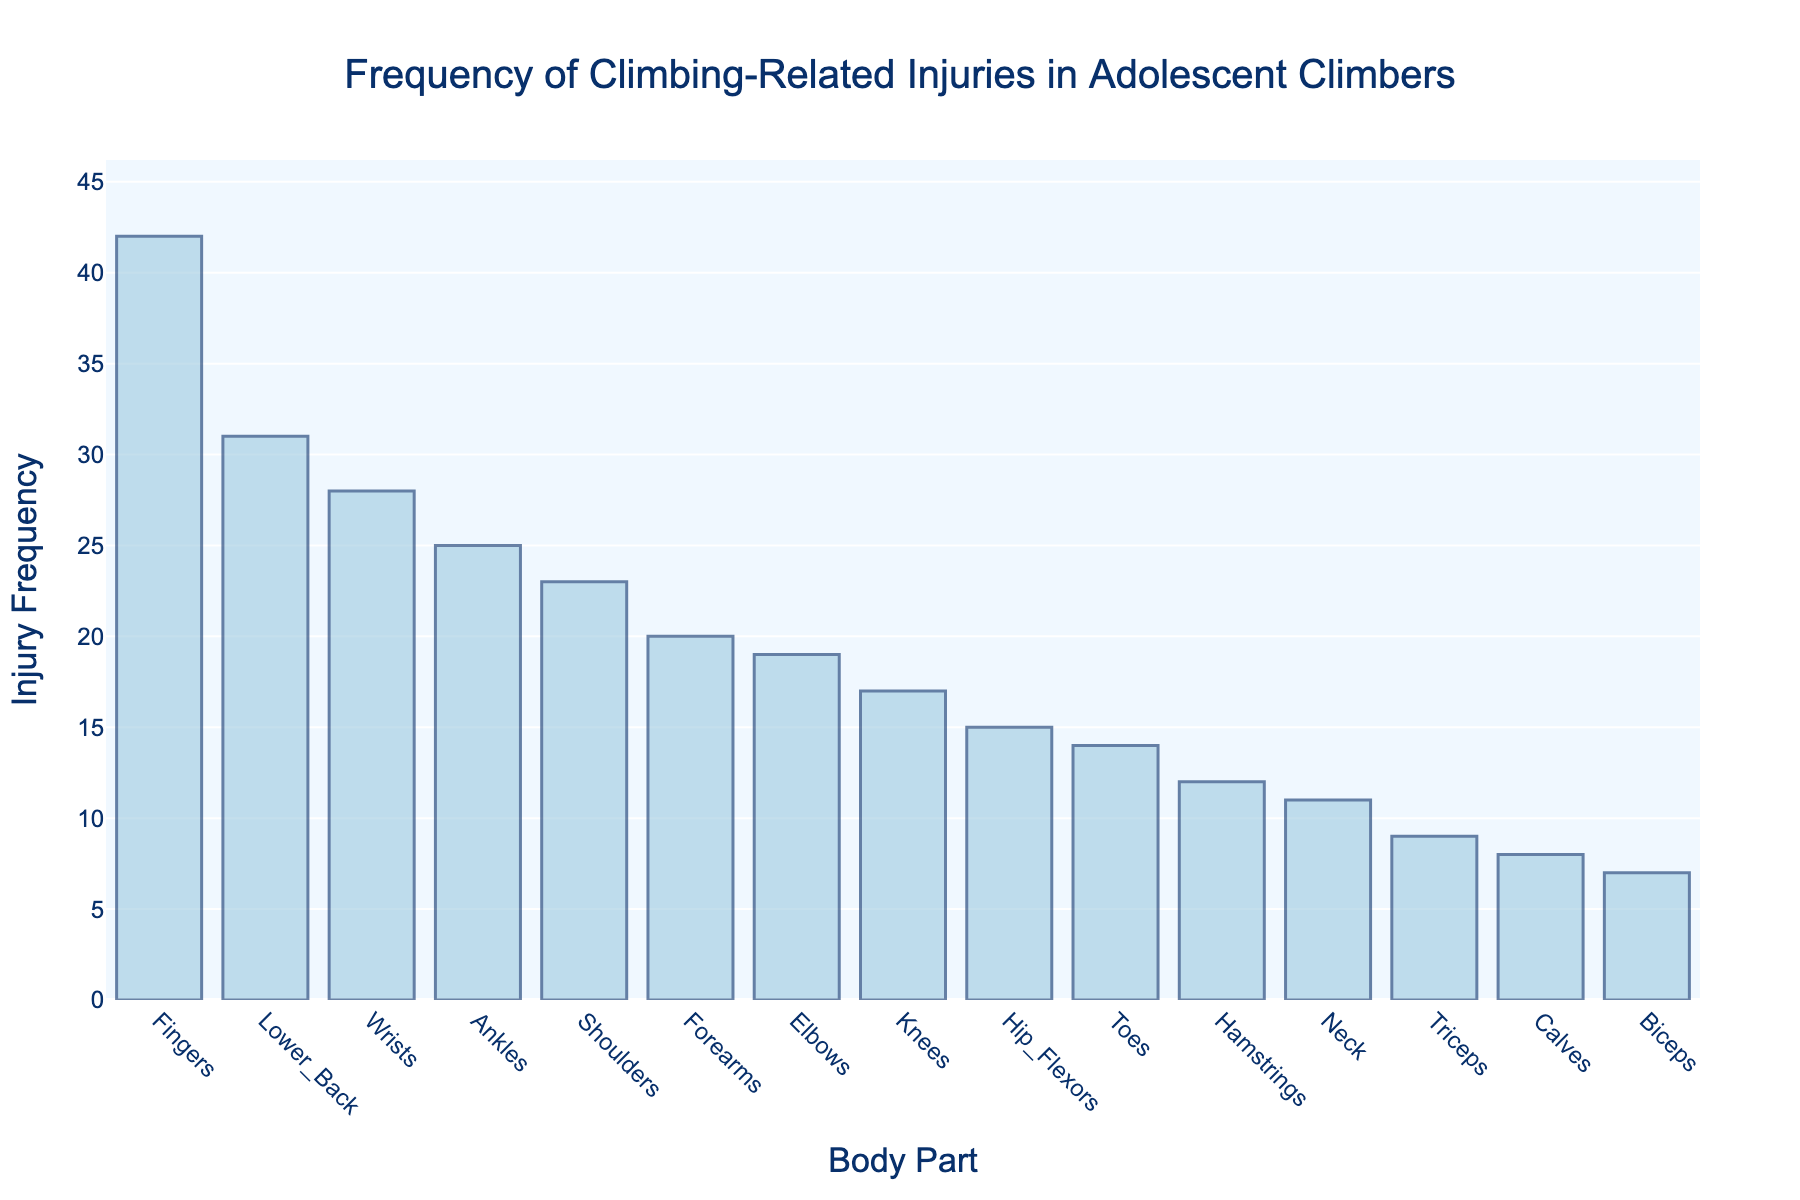Which body part has the highest injury frequency? By looking at the highest bar in the Manhattan plot, we can identify the body part with the highest injury frequency.
Answer: Fingers What is the injury frequency for the shoulders? Locate the bar labeled "Shoulders" on the x-axis and read the corresponding y-axis value.
Answer: 23 How many body parts have an injury frequency greater than 20? Count the bars that extend above the 20 mark on the y-axis.
Answer: 5 What's the difference in injury frequency between the fingers and the elbows? Find the y-values for "Fingers" and "Elbows", then subtract the value for "Elbows" from that of "Fingers" (42 - 19).
Answer: 23 Are there any body parts with an injury frequency of less than 10? If so, which ones? Identify the bars with y-values less than 10 by examining their heights and labels.
Answer: Triceps, Biceps, Calves Which two body parts have the closest injury frequencies? Find pairs of bars that are closest in height and compare their y-values.
Answer: Elbows and Forearms What's the average injury frequency of the given body parts? Sum all the injury frequencies and divide by the number of body parts (42+28+19+23+31+17+25+14+11+20+9+7+12+8+15)/15.
Answer: 19.8 How many body parts have an injury frequency between 10 and 20 inclusive? Count the bars whose y-values fall within the range 10 to 20 inclusive.
Answer: 7 What is the total injury frequency for the lower back and the neck? Add the injury frequencies of "Lower_Back" and "Neck" (31 + 11).
Answer: 42 How many bars represent injuries with a frequency above the average frequency? Calculate the average injury frequency and count the bars with y-values above this average.
Answer: 6 